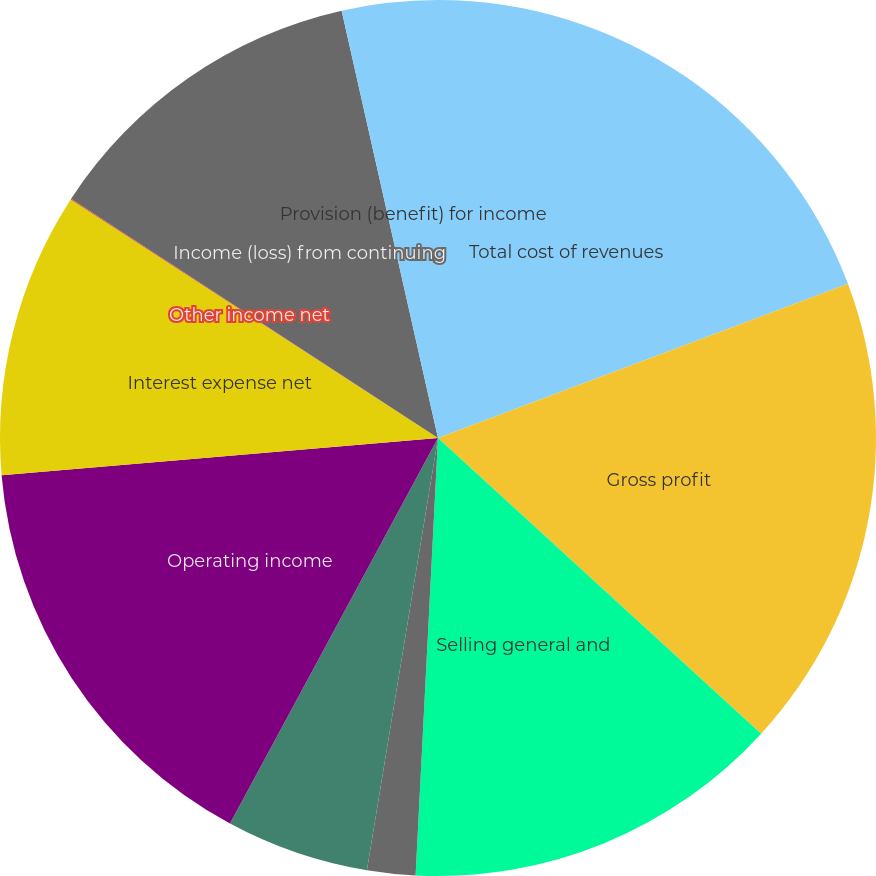Convert chart. <chart><loc_0><loc_0><loc_500><loc_500><pie_chart><fcel>Total cost of revenues<fcel>Gross profit<fcel>Selling general and<fcel>Restructuring charge<fcel>Non-rental depreciation and<fcel>Operating income<fcel>Interest expense net<fcel>Other income net<fcel>Income (loss) from continuing<fcel>Provision (benefit) for income<nl><fcel>19.27%<fcel>17.52%<fcel>14.02%<fcel>1.78%<fcel>5.28%<fcel>15.77%<fcel>10.52%<fcel>0.03%<fcel>12.27%<fcel>3.53%<nl></chart> 